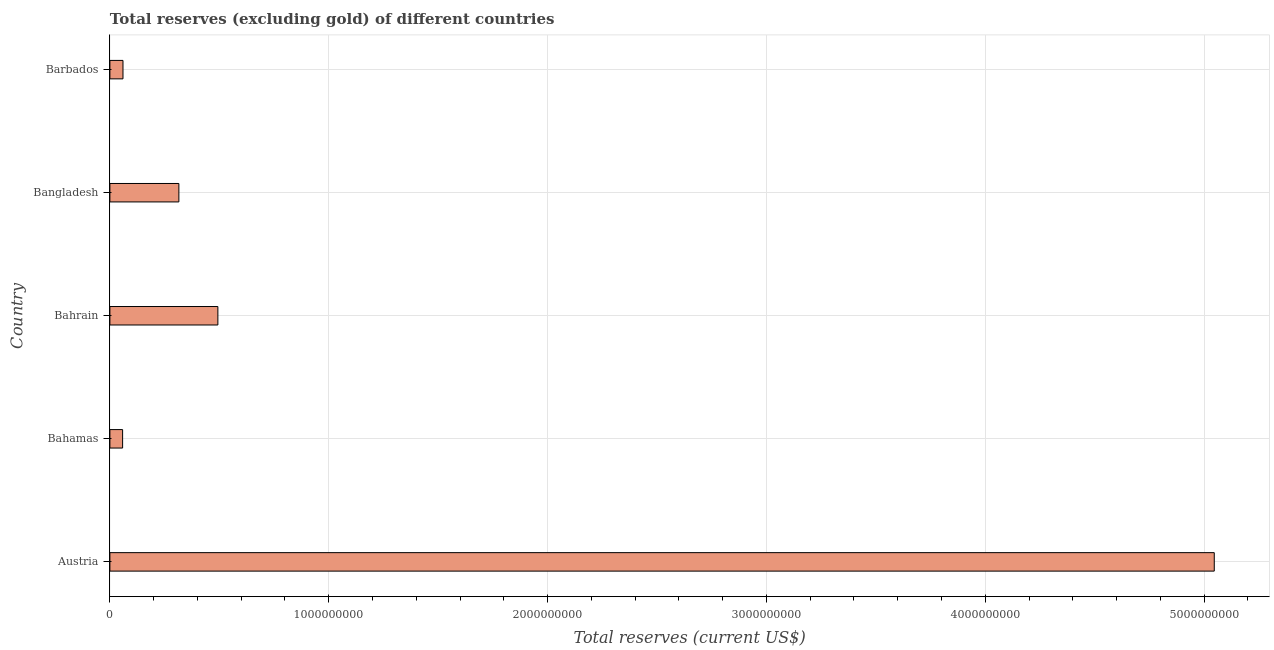Does the graph contain grids?
Your response must be concise. Yes. What is the title of the graph?
Your answer should be very brief. Total reserves (excluding gold) of different countries. What is the label or title of the X-axis?
Offer a very short reply. Total reserves (current US$). What is the total reserves (excluding gold) in Austria?
Provide a succinct answer. 5.05e+09. Across all countries, what is the maximum total reserves (excluding gold)?
Keep it short and to the point. 5.05e+09. Across all countries, what is the minimum total reserves (excluding gold)?
Ensure brevity in your answer.  5.81e+07. In which country was the total reserves (excluding gold) minimum?
Offer a very short reply. Bahamas. What is the sum of the total reserves (excluding gold)?
Your answer should be very brief. 5.97e+09. What is the difference between the total reserves (excluding gold) in Bahrain and Barbados?
Give a very brief answer. 4.34e+08. What is the average total reserves (excluding gold) per country?
Your answer should be very brief. 1.19e+09. What is the median total reserves (excluding gold)?
Ensure brevity in your answer.  3.15e+08. What is the ratio of the total reserves (excluding gold) in Bahamas to that in Barbados?
Keep it short and to the point. 0.97. Is the total reserves (excluding gold) in Bahamas less than that in Bangladesh?
Keep it short and to the point. Yes. Is the difference between the total reserves (excluding gold) in Bangladesh and Barbados greater than the difference between any two countries?
Your answer should be very brief. No. What is the difference between the highest and the second highest total reserves (excluding gold)?
Provide a succinct answer. 4.55e+09. What is the difference between the highest and the lowest total reserves (excluding gold)?
Provide a succinct answer. 4.99e+09. In how many countries, is the total reserves (excluding gold) greater than the average total reserves (excluding gold) taken over all countries?
Keep it short and to the point. 1. How many countries are there in the graph?
Make the answer very short. 5. What is the difference between two consecutive major ticks on the X-axis?
Make the answer very short. 1.00e+09. Are the values on the major ticks of X-axis written in scientific E-notation?
Make the answer very short. No. What is the Total reserves (current US$) in Austria?
Your answer should be very brief. 5.05e+09. What is the Total reserves (current US$) of Bahamas?
Your answer should be very brief. 5.81e+07. What is the Total reserves (current US$) in Bahrain?
Your response must be concise. 4.93e+08. What is the Total reserves (current US$) of Bangladesh?
Provide a succinct answer. 3.15e+08. What is the Total reserves (current US$) in Barbados?
Ensure brevity in your answer.  5.98e+07. What is the difference between the Total reserves (current US$) in Austria and Bahamas?
Ensure brevity in your answer.  4.99e+09. What is the difference between the Total reserves (current US$) in Austria and Bahrain?
Offer a terse response. 4.55e+09. What is the difference between the Total reserves (current US$) in Austria and Bangladesh?
Keep it short and to the point. 4.73e+09. What is the difference between the Total reserves (current US$) in Austria and Barbados?
Make the answer very short. 4.99e+09. What is the difference between the Total reserves (current US$) in Bahamas and Bahrain?
Keep it short and to the point. -4.35e+08. What is the difference between the Total reserves (current US$) in Bahamas and Bangladesh?
Offer a terse response. -2.57e+08. What is the difference between the Total reserves (current US$) in Bahamas and Barbados?
Your response must be concise. -1.72e+06. What is the difference between the Total reserves (current US$) in Bahrain and Bangladesh?
Provide a succinct answer. 1.78e+08. What is the difference between the Total reserves (current US$) in Bahrain and Barbados?
Provide a short and direct response. 4.34e+08. What is the difference between the Total reserves (current US$) in Bangladesh and Barbados?
Provide a succinct answer. 2.55e+08. What is the ratio of the Total reserves (current US$) in Austria to that in Bahamas?
Your answer should be compact. 86.83. What is the ratio of the Total reserves (current US$) in Austria to that in Bahrain?
Your answer should be very brief. 10.23. What is the ratio of the Total reserves (current US$) in Austria to that in Bangladesh?
Offer a terse response. 16.01. What is the ratio of the Total reserves (current US$) in Austria to that in Barbados?
Provide a short and direct response. 84.34. What is the ratio of the Total reserves (current US$) in Bahamas to that in Bahrain?
Give a very brief answer. 0.12. What is the ratio of the Total reserves (current US$) in Bahamas to that in Bangladesh?
Provide a succinct answer. 0.18. What is the ratio of the Total reserves (current US$) in Bahrain to that in Bangladesh?
Your answer should be compact. 1.56. What is the ratio of the Total reserves (current US$) in Bahrain to that in Barbados?
Make the answer very short. 8.25. What is the ratio of the Total reserves (current US$) in Bangladesh to that in Barbados?
Your response must be concise. 5.27. 